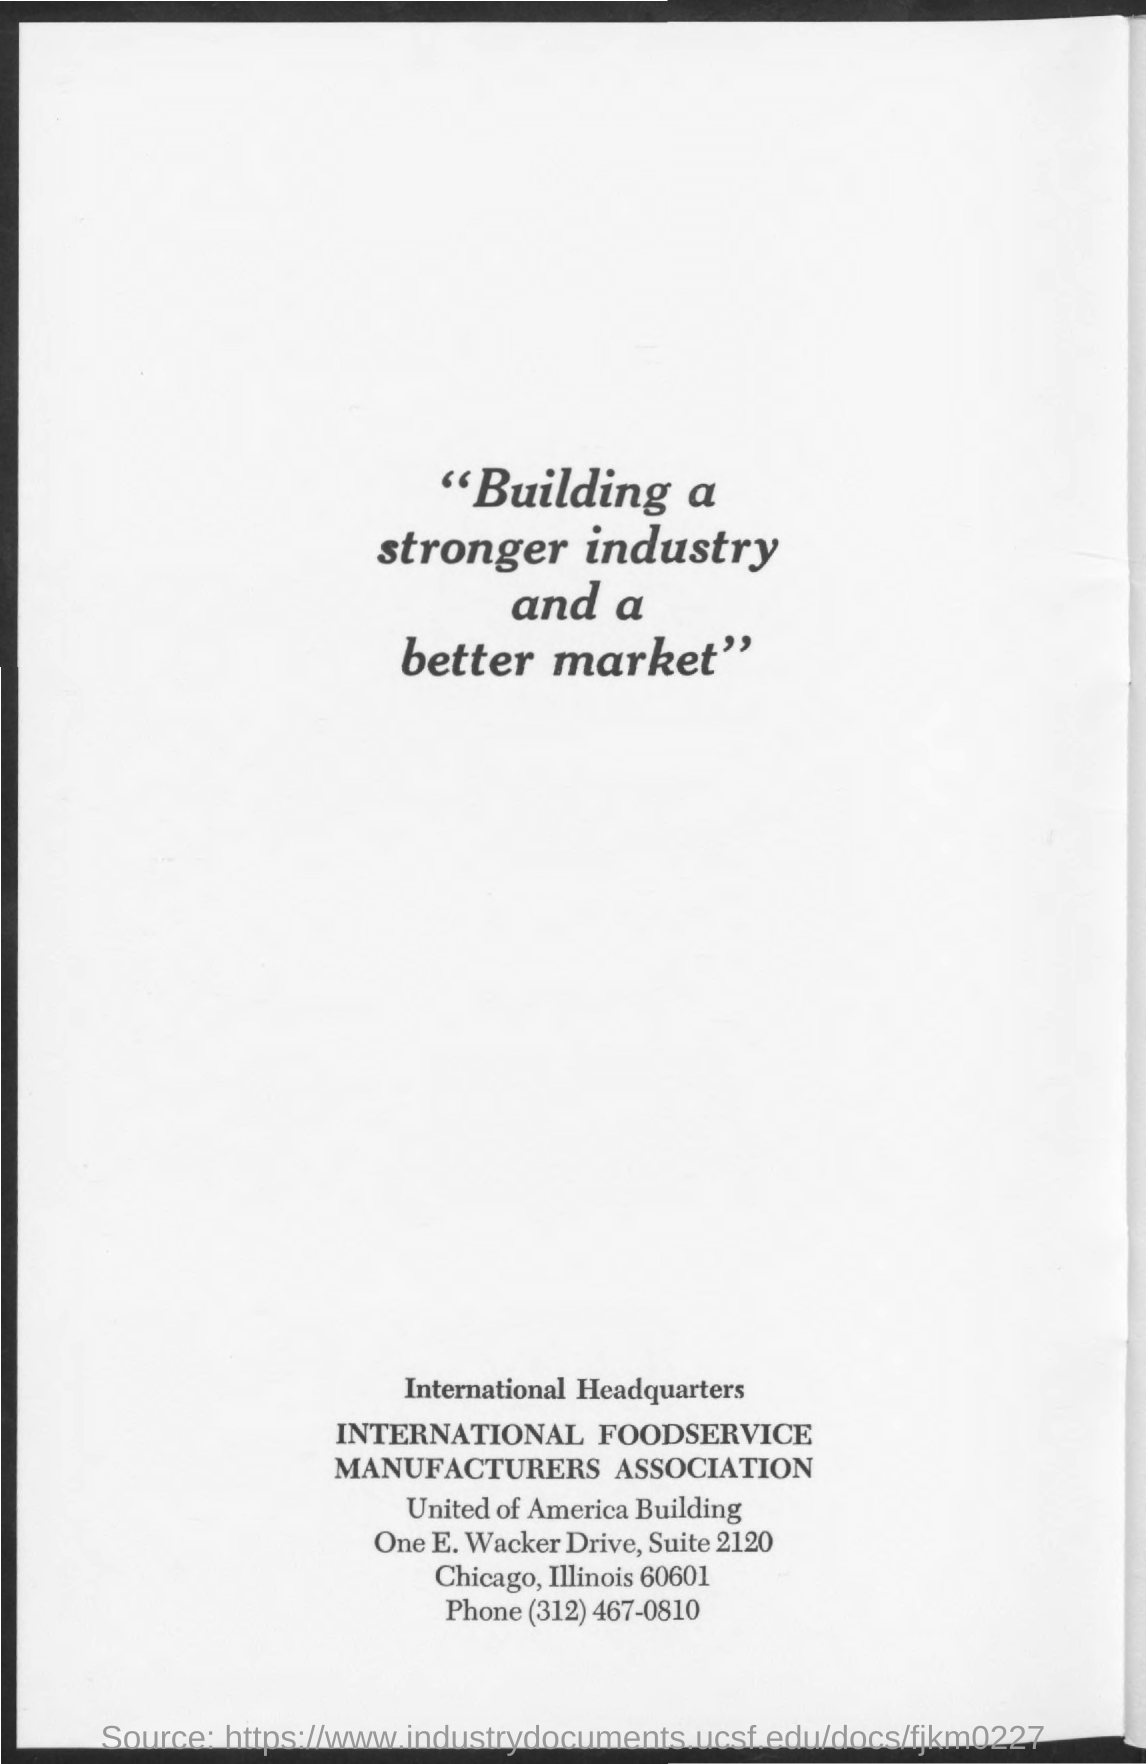What is the quotation written in the given page ?
Make the answer very short. "Building a stronger industry and a better market". What is the phone number mentioned in the given page ?
Keep it short and to the point. (312) 467-0810. 